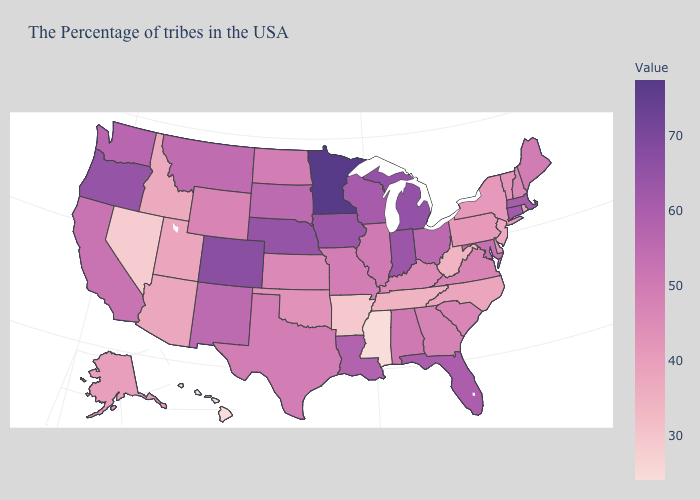Does Alabama have the highest value in the USA?
Keep it brief. No. Among the states that border Massachusetts , which have the lowest value?
Give a very brief answer. Rhode Island. Does the map have missing data?
Write a very short answer. No. Does the map have missing data?
Short answer required. No. Among the states that border Connecticut , which have the highest value?
Short answer required. Massachusetts. Does North Carolina have a lower value than Mississippi?
Write a very short answer. No. Is the legend a continuous bar?
Concise answer only. Yes. Which states have the lowest value in the South?
Quick response, please. Mississippi. Which states have the highest value in the USA?
Keep it brief. Minnesota. Among the states that border Texas , does Arkansas have the lowest value?
Be succinct. Yes. Does the map have missing data?
Keep it brief. No. Which states have the lowest value in the USA?
Answer briefly. Mississippi, Hawaii. 